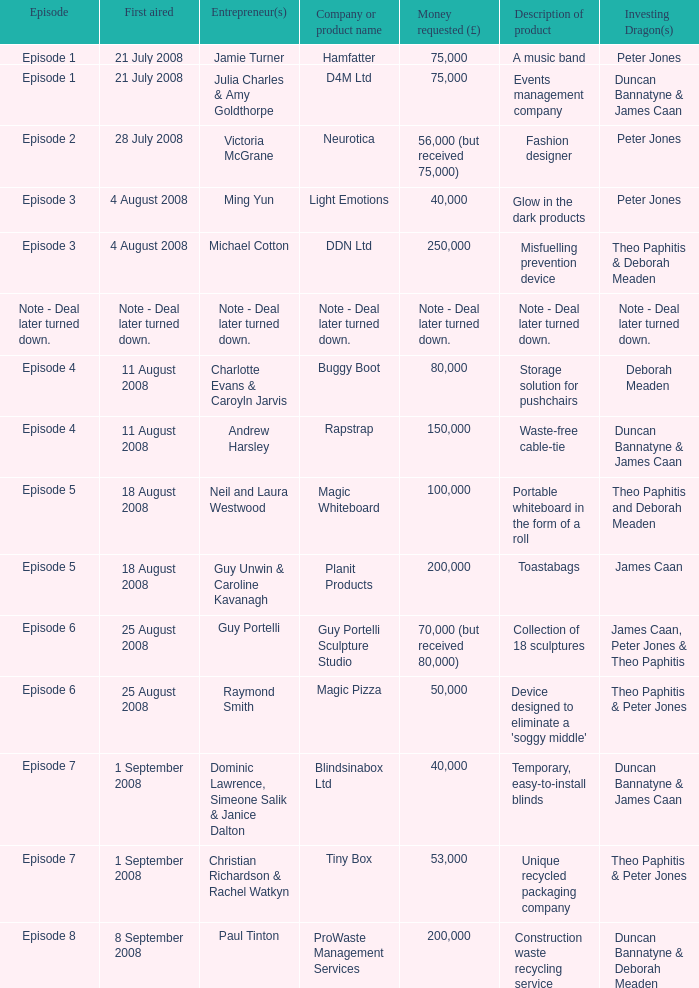Who is the company Investing Dragons, or tiny box? Theo Paphitis & Peter Jones. 